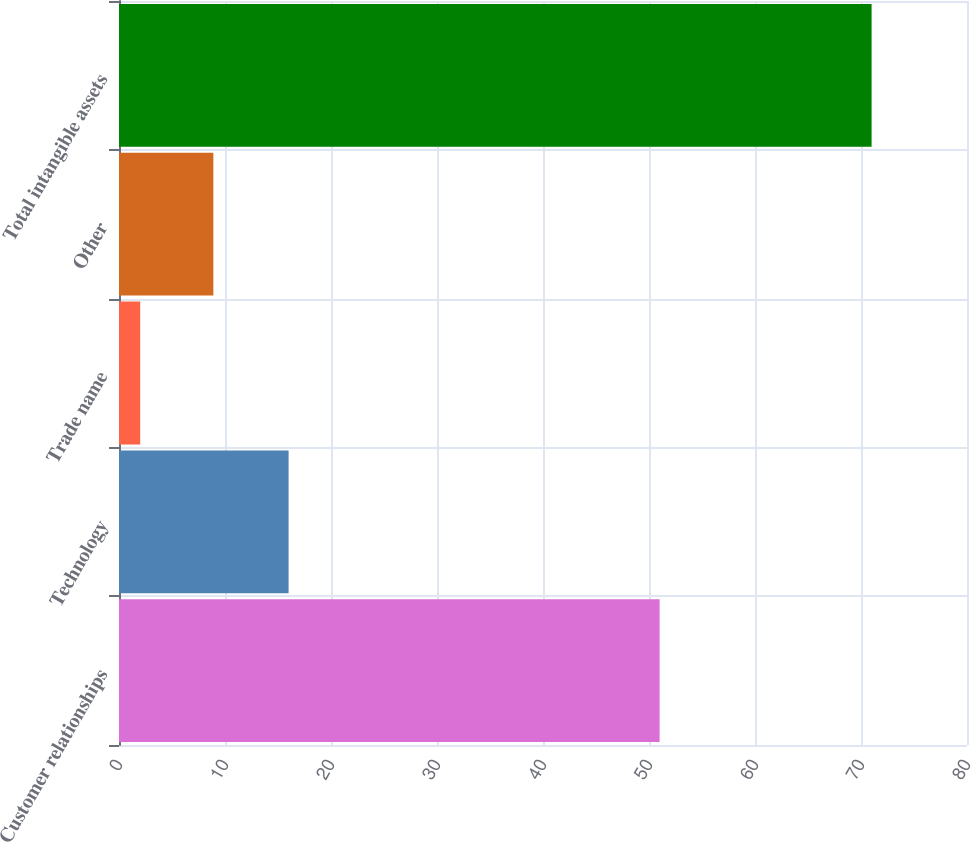Convert chart. <chart><loc_0><loc_0><loc_500><loc_500><bar_chart><fcel>Customer relationships<fcel>Technology<fcel>Trade name<fcel>Other<fcel>Total intangible assets<nl><fcel>51<fcel>16<fcel>2<fcel>8.9<fcel>71<nl></chart> 